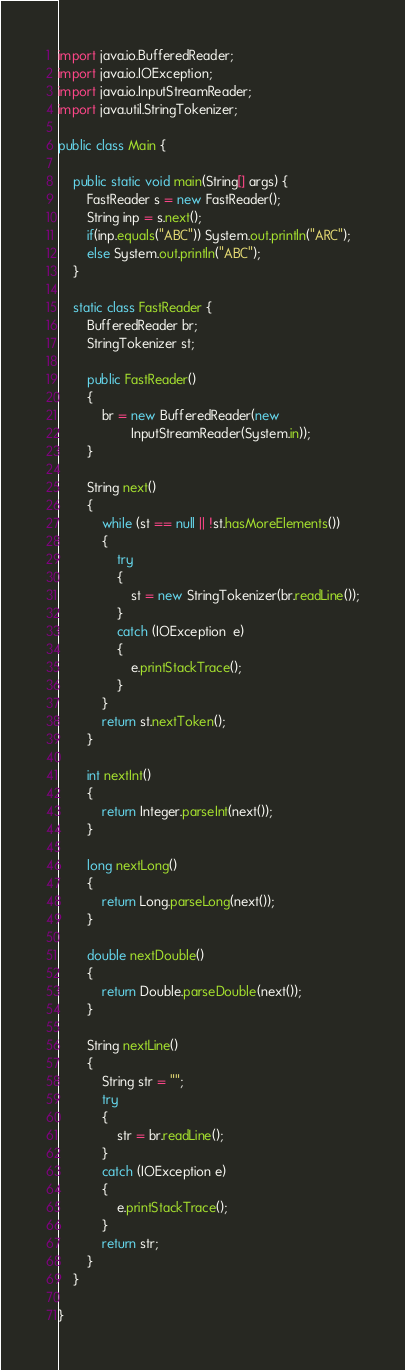Convert code to text. <code><loc_0><loc_0><loc_500><loc_500><_Java_>import java.io.BufferedReader;
import java.io.IOException;
import java.io.InputStreamReader;
import java.util.StringTokenizer;

public class Main {

	public static void main(String[] args) {
		FastReader s = new FastReader();
		String inp = s.next();
		if(inp.equals("ABC")) System.out.println("ARC");
		else System.out.println("ABC");
	}
	
	static class FastReader {
        BufferedReader br;
        StringTokenizer st;
 
        public FastReader()
        {
            br = new BufferedReader(new
                    InputStreamReader(System.in));
        }
 
        String next()
        {
            while (st == null || !st.hasMoreElements())
            {
                try
                {
                    st = new StringTokenizer(br.readLine());
                }
                catch (IOException  e)
                {
                    e.printStackTrace();
                }
            }
            return st.nextToken();
        }
 
        int nextInt()
        {
            return Integer.parseInt(next());
        }
 
        long nextLong()
        {
            return Long.parseLong(next());
        }
 
        double nextDouble()
        {
            return Double.parseDouble(next());
        }
 
        String nextLine()
        {
            String str = "";
            try
            {
                str = br.readLine();
            }
            catch (IOException e)
            {
                e.printStackTrace();
            }
            return str;
        }
	}

}
</code> 